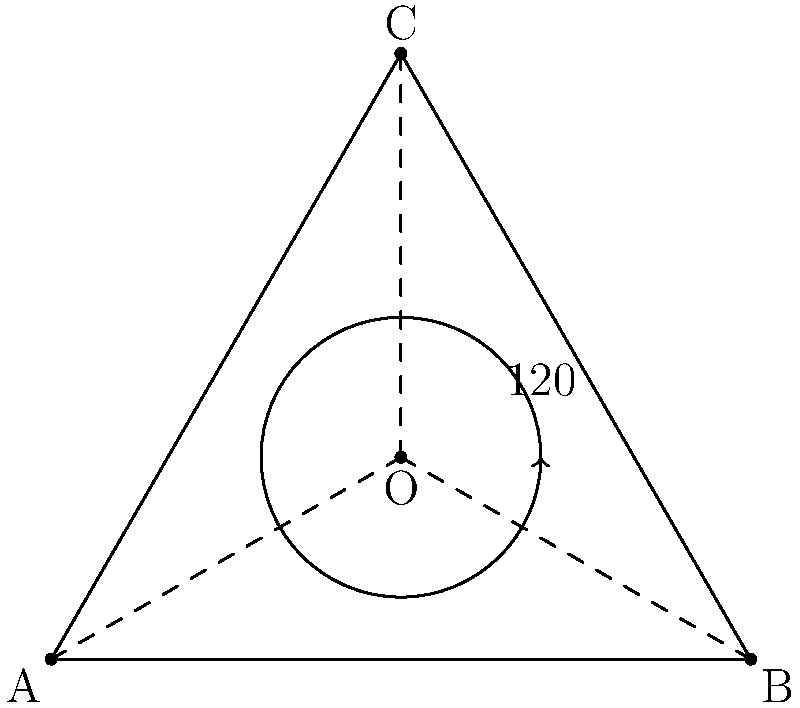In the regular triangle ABC, point O is the center of rotation. If the triangle is rotated $120°$ clockwise around O, which spiritual principle does this geometric transformation most closely represent, and what fraction of a full rotation is this movement? To understand the spiritual significance and mathematical properties of this rotation:

1. Recognize that the regular triangle ABC represents perfect balance and harmony, often associated with divine trinities in many spiritual traditions.

2. The center point O symbolizes the divine axis or source of creation around which all rotates.

3. The $120°$ rotation is significant because:
   a. It's exactly one-third of a full $360°$ rotation.
   b. It maps each vertex onto another, preserving the triangle's shape and symmetry.

4. This rotation represents:
   a. The cyclical nature of creation and spiritual transformation.
   b. The interconnectedness of all parts within a whole.
   c. The concept of "As above, so below" - the microcosm reflecting the macrocosm.

5. Mathematically, $120°$ is $\frac{1}{3}$ of a full rotation:
   $$\frac{120°}{360°} = \frac{1}{3}$$

6. This fraction ($\frac{1}{3}$) often represents completeness or wholeness in spiritual numerology, reinforcing the idea of divine perfection in the triangle's symmetry.
Answer: Divine harmony; $\frac{1}{3}$ 